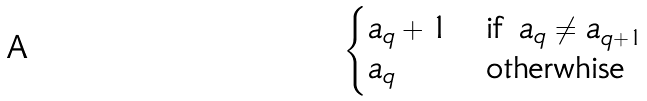Convert formula to latex. <formula><loc_0><loc_0><loc_500><loc_500>\begin{cases} a _ { q } + 1 & \text {if $a_{q}\neq a_{q+1}$} \\ a _ { q } & \text {otherwhise} \end{cases}</formula> 